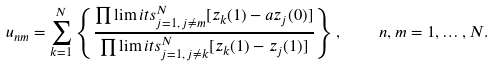Convert formula to latex. <formula><loc_0><loc_0><loc_500><loc_500>u _ { n m } = \sum _ { k = 1 } ^ { N } \left \{ \frac { \prod \lim i t s _ { j = 1 , \, j \neq m } ^ { N } [ z _ { k } ( 1 ) - a z _ { j } ( 0 ) ] } { \prod \lim i t s _ { j = 1 , \, j \neq k } ^ { N } [ z _ { k } ( 1 ) - z _ { j } ( 1 ) ] } \right \} , \quad n , m = 1 , \dots , N .</formula> 